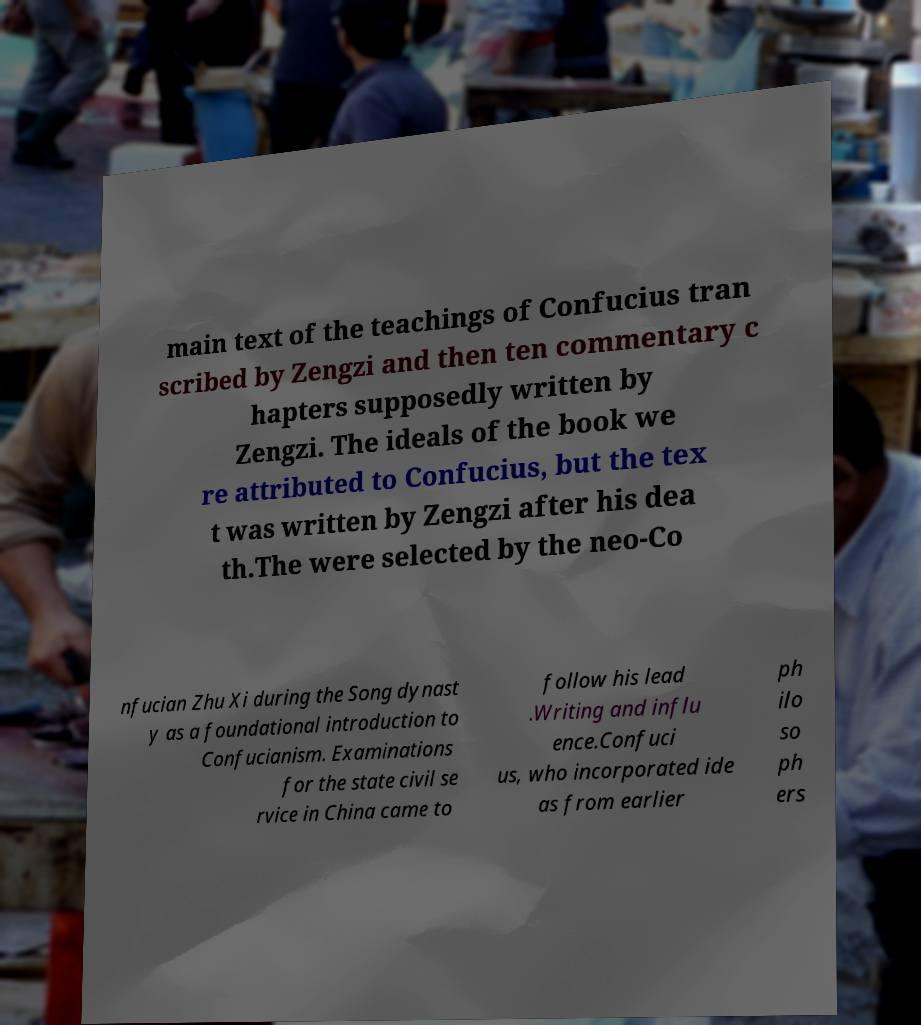Could you assist in decoding the text presented in this image and type it out clearly? main text of the teachings of Confucius tran scribed by Zengzi and then ten commentary c hapters supposedly written by Zengzi. The ideals of the book we re attributed to Confucius, but the tex t was written by Zengzi after his dea th.The were selected by the neo-Co nfucian Zhu Xi during the Song dynast y as a foundational introduction to Confucianism. Examinations for the state civil se rvice in China came to follow his lead .Writing and influ ence.Confuci us, who incorporated ide as from earlier ph ilo so ph ers 